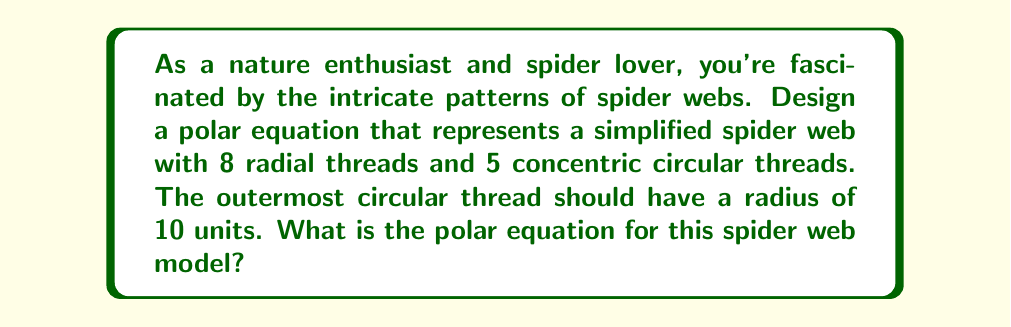Help me with this question. Let's approach this step-by-step:

1) For the radial threads, we can use the equation:
   $$r = \sin(n\theta)$$
   where $n$ is the number of radial threads. In this case, $n = 8$.

2) For the concentric circular threads, we can use:
   $$r = a$$
   where $a$ is the radius of each circle. We need 5 circles with the outermost having a radius of 10.

3) To combine these, we can use the product of these equations:
   $$r = 10 \cdot \sin(8\theta) \cdot \left(\frac{1}{5} + \frac{2}{5} + \frac{3}{5} + \frac{4}{5} + 1\right)$$

4) Simplify the sum in parentheses:
   $$\frac{1}{5} + \frac{2}{5} + \frac{3}{5} + \frac{4}{5} + 1 = 3$$

5) Our final equation becomes:
   $$r = 30 \cdot \sin(8\theta)$$

This equation will create a pattern with 8 radial threads (due to $\sin(8\theta)$) and 5 concentric circular threads (due to the multiplication by 30, which creates peaks at 6, 12, 18, 24, and 30).
Answer: $r = 30 \sin(8\theta)$ 